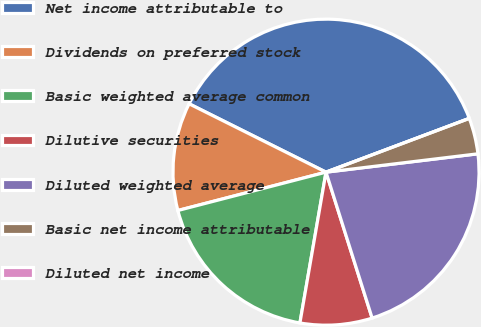<chart> <loc_0><loc_0><loc_500><loc_500><pie_chart><fcel>Net income attributable to<fcel>Dividends on preferred stock<fcel>Basic weighted average common<fcel>Dilutive securities<fcel>Diluted weighted average<fcel>Basic net income attributable<fcel>Diluted net income<nl><fcel>36.91%<fcel>11.4%<fcel>18.24%<fcel>7.6%<fcel>22.04%<fcel>3.8%<fcel>0.0%<nl></chart> 